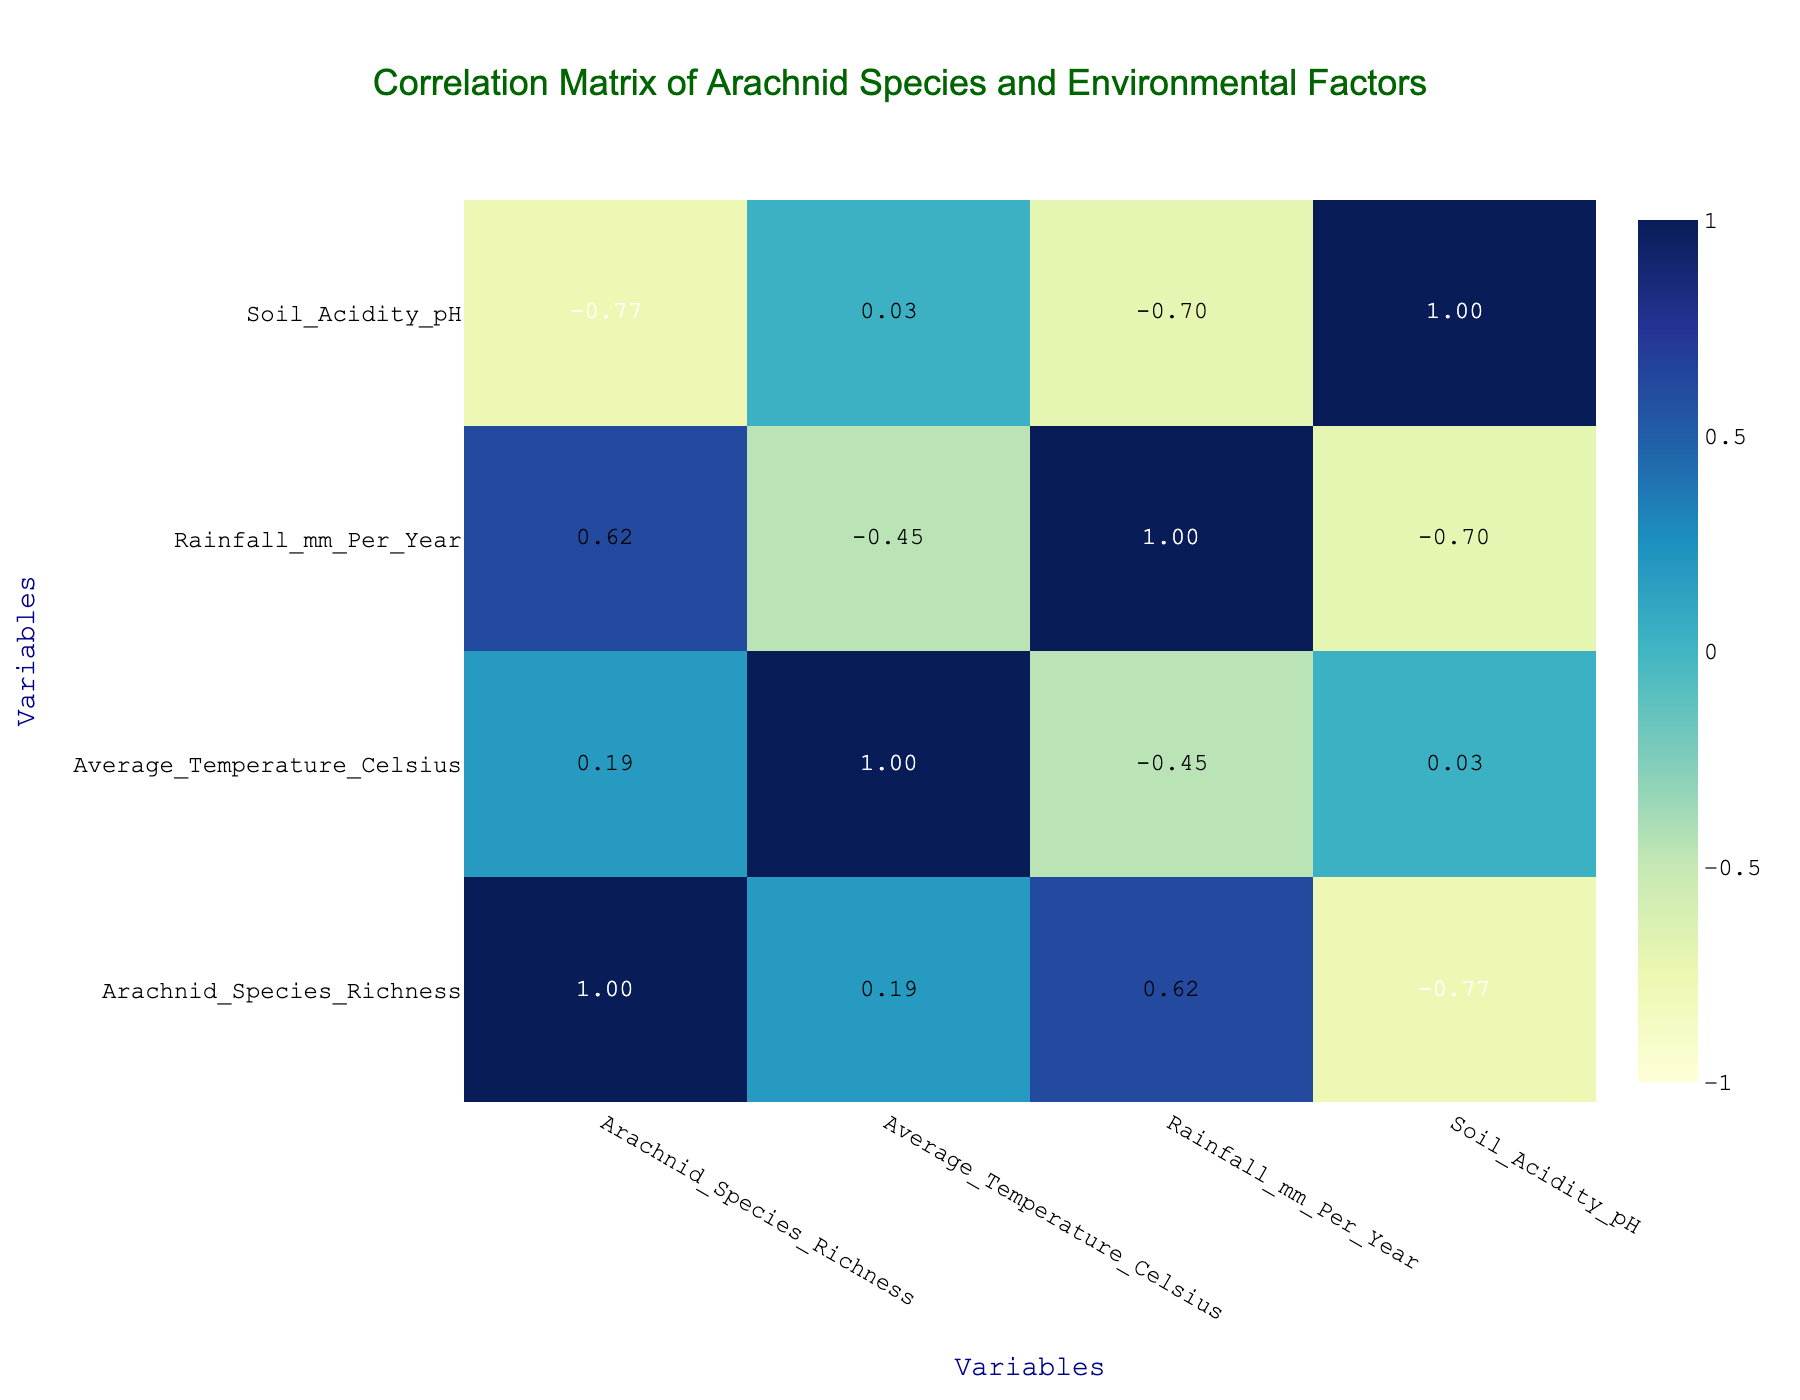What is the arachnid species richness in Bahia? From the table, Bahia shows an arachnid species richness of 120.
Answer: 120 Which region has the highest average temperature? By examining the average temperature values in the table, Ceará has the highest temperature at 27.5 degrees Celsius.
Answer: Ceará Is the average temperature in Amazonas higher than in Espírito Santo? Looking at the average temperatures, Amazonas (25.0) is lower than Espírito Santo (25.8), so the answer is no.
Answer: No What is the difference in rainfall between the region with the highest and lowest rainfall? The highest rainfall is in Amazonas with 2100 mm, and the lowest is in Ceará with 800 mm. The difference is 2100 - 800 = 1300 mm.
Answer: 1300 mm Which region has the lowest soil acidity? The soil acidity pH values show that Amazonas has the lowest at 5.4.
Answer: Amazonas Is the arachnid species richness positively correlated with average temperature? By observing the correlation value in the table, if it is greater than 0, it indicates a positive correlation. The exact value will show if they are positively correlated.
Answer: Yes (if >0) What is the average species richness for regions with rainforest vegetation types? The regions with rainforest vegetation are Acre (150), Amazonas (180), and Espírito Santo (130). The average is (150 + 180 + 130) / 3 = 153.33, rounding down gives an average of 153.
Answer: 153 Which region has the highest species richness among areas with savanna vegetation? Among the regions with savanna vegetation, Ceará has 90 species and Sergipe has 100 species. Thus, Sergipe has the highest species richness in this category.
Answer: Sergipe What is the average pH of soil acidity across all regions? To find the average, we sum all the pH values (5.5 + 5.4 + 6.0 + 6.8 + 5.9 + 6.1 + 5.6 + 5.7 + 6.4 + 6.2) = 60.7 and divide by the number of regions (10). The average is 60.7 / 10 = 6.07.
Answer: 6.07 